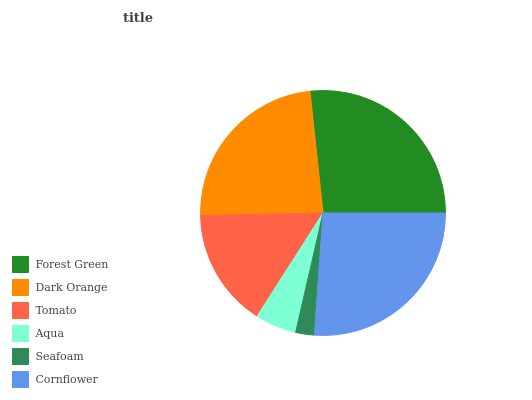Is Seafoam the minimum?
Answer yes or no. Yes. Is Forest Green the maximum?
Answer yes or no. Yes. Is Dark Orange the minimum?
Answer yes or no. No. Is Dark Orange the maximum?
Answer yes or no. No. Is Forest Green greater than Dark Orange?
Answer yes or no. Yes. Is Dark Orange less than Forest Green?
Answer yes or no. Yes. Is Dark Orange greater than Forest Green?
Answer yes or no. No. Is Forest Green less than Dark Orange?
Answer yes or no. No. Is Dark Orange the high median?
Answer yes or no. Yes. Is Tomato the low median?
Answer yes or no. Yes. Is Cornflower the high median?
Answer yes or no. No. Is Dark Orange the low median?
Answer yes or no. No. 